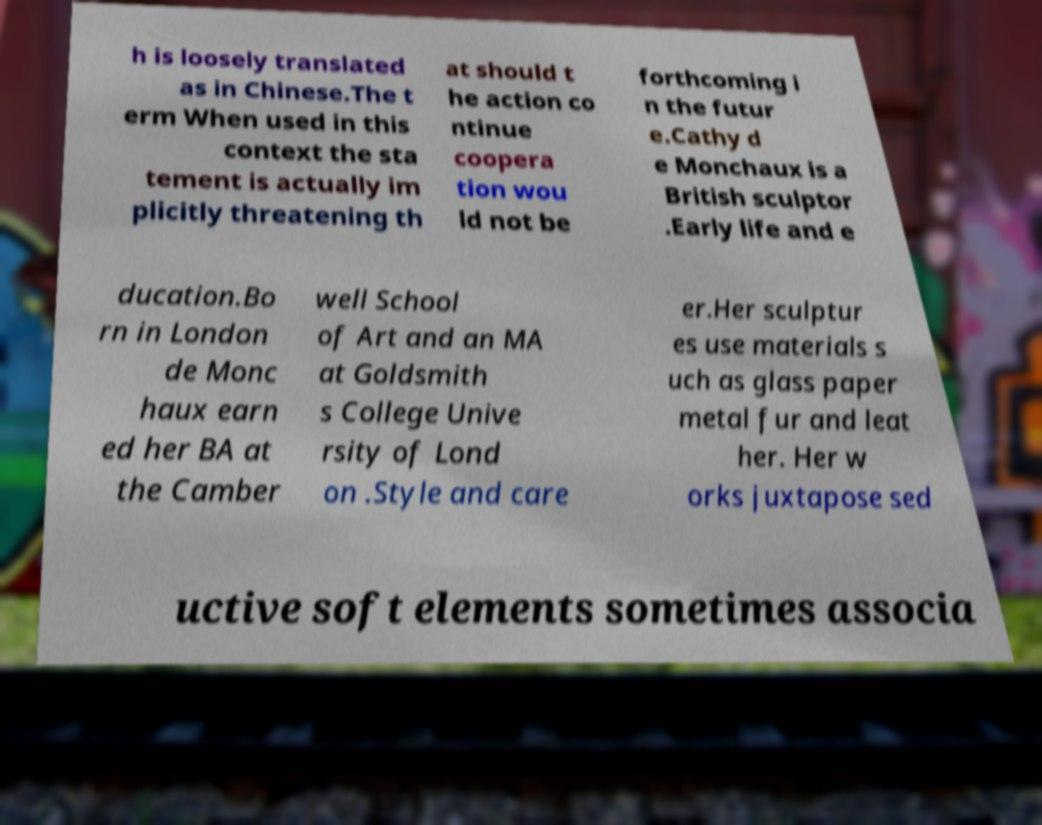Please read and relay the text visible in this image. What does it say? h is loosely translated as in Chinese.The t erm When used in this context the sta tement is actually im plicitly threatening th at should t he action co ntinue coopera tion wou ld not be forthcoming i n the futur e.Cathy d e Monchaux is a British sculptor .Early life and e ducation.Bo rn in London de Monc haux earn ed her BA at the Camber well School of Art and an MA at Goldsmith s College Unive rsity of Lond on .Style and care er.Her sculptur es use materials s uch as glass paper metal fur and leat her. Her w orks juxtapose sed uctive soft elements sometimes associa 